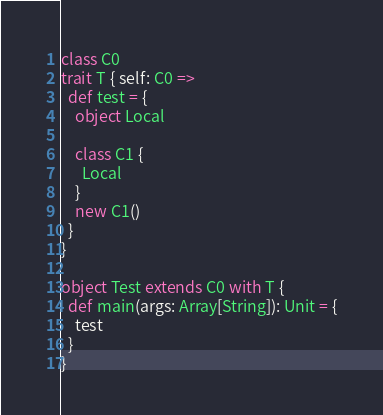<code> <loc_0><loc_0><loc_500><loc_500><_Scala_>class C0
trait T { self: C0 =>
  def test = {
    object Local

    class C1 {
      Local
    }
    new C1()
  }
}

object Test extends C0 with T {
  def main(args: Array[String]): Unit = {
    test
  }
}
</code> 